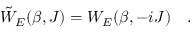<formula> <loc_0><loc_0><loc_500><loc_500>\tilde { W } _ { E } ( \beta , J ) = W _ { E } ( \beta , - i J ) .</formula> 